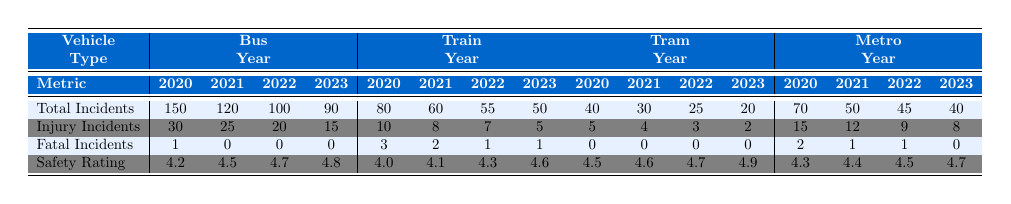What was the total number of incidents for buses in 2022? In the table, under the "Bus" section and the year "2022", the number of Total Incidents is listed as 100.
Answer: 100 Which vehicle type had the highest safety rating in 2023? Looking at the Safety Ratings for each vehicle type in 2023, the ratings are 4.8 for Bus, 4.6 for Train, 4.9 for Tram, and 4.7 for Metro. The highest is 4.9 for Tram.
Answer: Tram How many injury incidents were reported for trains in 2021? The table shows the Injury Incidents for Train in 2021 as 8.
Answer: 8 Did any vehicle type report zero fatal incidents in 2023? Referring to the Fatal Incidents for each vehicle type in 2023, both Bus and Tram reported zero fatal incidents. Thus, the statement is true.
Answer: Yes What is the difference in total incidents between buses in 2020 and 2023? Total Incidents for Bus in 2020 is 150, and in 2023 is 90. The difference is calculated as 150 - 90 = 60.
Answer: 60 What was the average safety rating for trams from 2020 to 2023? The Safety Ratings for Tram are 4.5, 4.6, 4.7, and 4.9 for the respective years. Summing these gives 4.5 + 4.6 + 4.7 + 4.9 = 19.7. Dividing by 4 gives an average of 4.925.
Answer: 4.93 Which vehicle type had the least number of total incidents in 2021? The table lists total incidents for each vehicle type in 2021: Bus (120), Train (60), Tram (30), and Metro (50). Tram has the lowest at 30 incidents.
Answer: Tram Is the number of injury incidents for buses decreasing over the years? Comparing the injury incidents over the years for Bus: 30 in 2020, 25 in 2021, 20 in 2022, and 15 in 2023, the values are indeed decreasing.
Answer: Yes What is the total number of fatal incidents reported for trains over the four years? The table shows Fatal Incidents for Train as 3 in 2020, 2 in 2021, 1 in 2022, and 1 in 2023. Summing these gives 3 + 2 + 1 + 1 = 7.
Answer: 7 What percentage of the total incidents for Metro in 2022 were injury incidents? Total incidents for Metro in 2022 is 45, with injury incidents being 9. The percentage is calculated as (9/45) * 100 = 20%.
Answer: 20% 